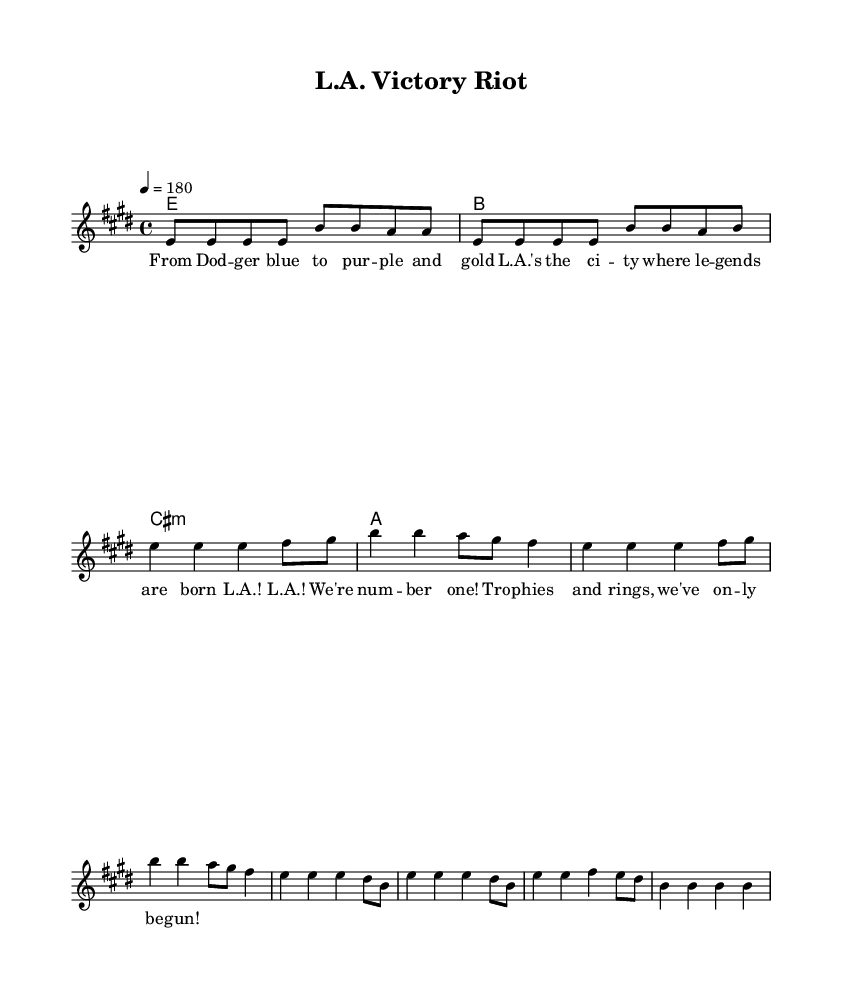What is the key signature of this music? The key signature indicates that there are four sharps, which corresponds to E major.
Answer: E major What is the time signature of this music? The time signature is shown in the first measure as 4/4, meaning there are four beats per measure.
Answer: 4/4 What is the tempo marking of this music? The tempo marking indicates a speed of 180 beats per minute, which is relatively fast for punk music.
Answer: 180 How many measures are in the verse section? The verse consists of two repeated sections of four measures each, totaling eight measures.
Answer: 8 What is the predominant theme of the lyrics? The lyrics celebrate Los Angeles sports victories, reflecting pride in the city's champions and sports culture.
Answer: Celebrating sports victories What is the primary musical technique used in punk for the guitar? The guitar features a repeated riff and power chords, which are characteristic of the punk genre, emphasizing simplicity and energy.
Answer: Power chords Which instrument is primarily featured in the score? The score is primarily written for guitar, with the guitar chords and riff being highlighted at the beginning.
Answer: Guitar 